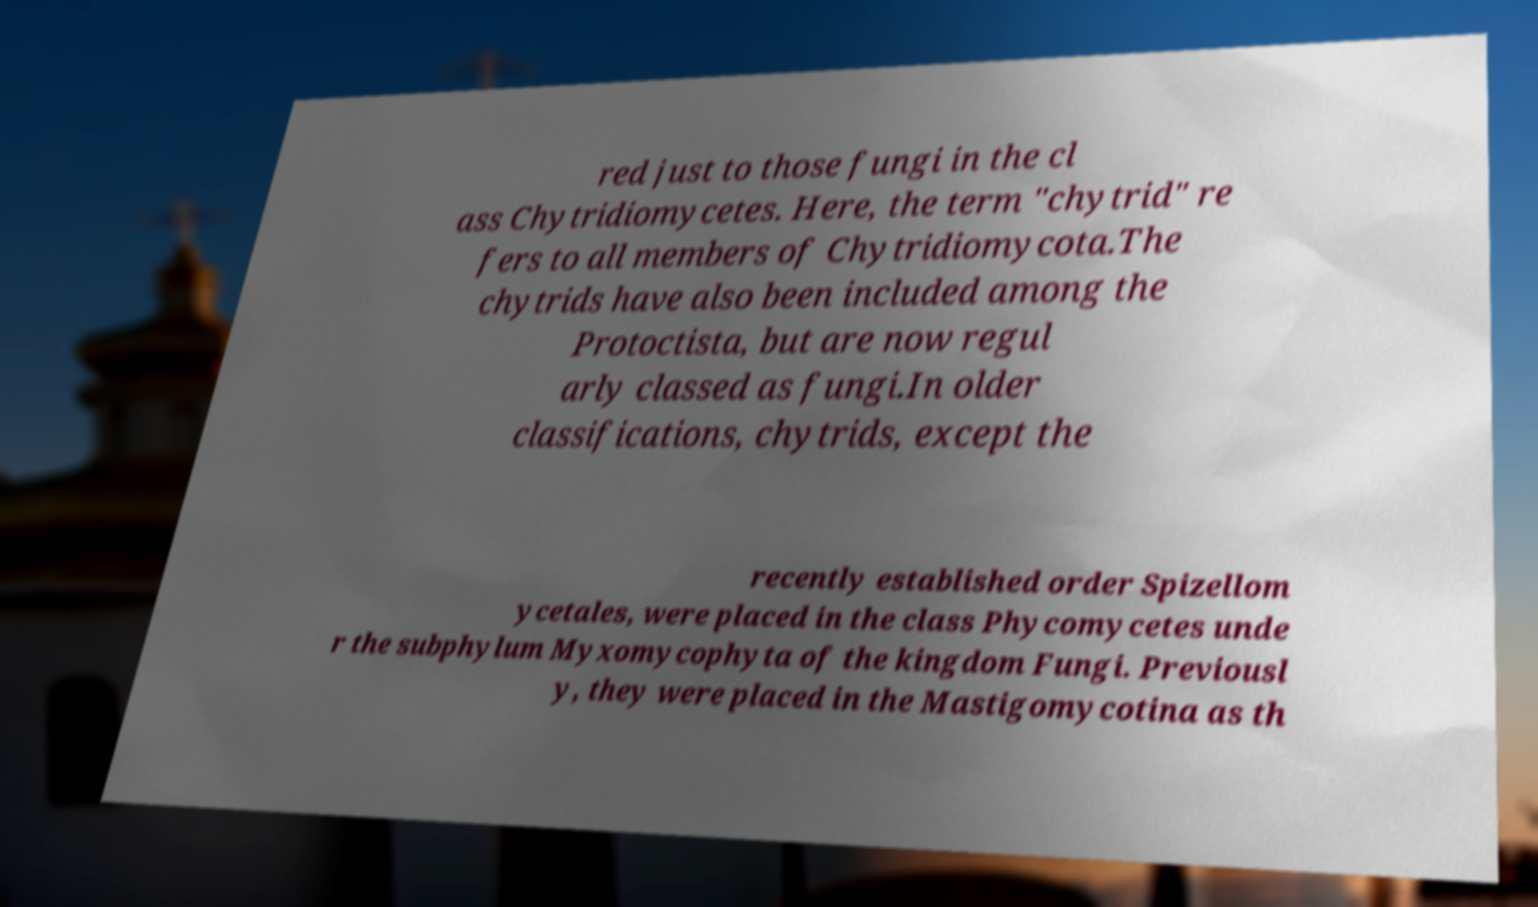There's text embedded in this image that I need extracted. Can you transcribe it verbatim? red just to those fungi in the cl ass Chytridiomycetes. Here, the term "chytrid" re fers to all members of Chytridiomycota.The chytrids have also been included among the Protoctista, but are now regul arly classed as fungi.In older classifications, chytrids, except the recently established order Spizellom ycetales, were placed in the class Phycomycetes unde r the subphylum Myxomycophyta of the kingdom Fungi. Previousl y, they were placed in the Mastigomycotina as th 